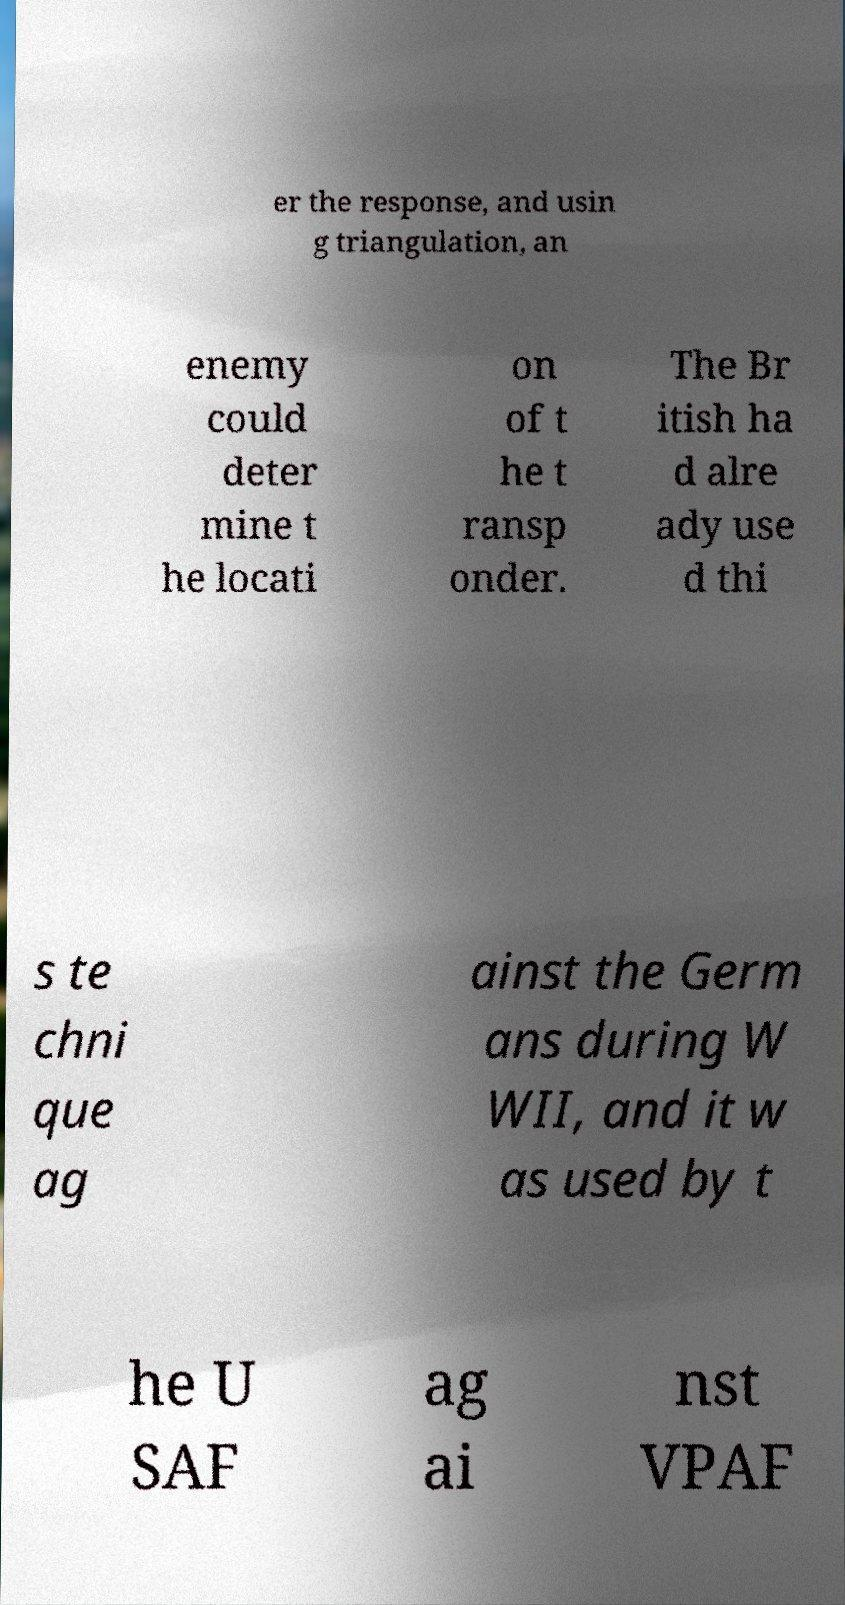Could you extract and type out the text from this image? er the response, and usin g triangulation, an enemy could deter mine t he locati on of t he t ransp onder. The Br itish ha d alre ady use d thi s te chni que ag ainst the Germ ans during W WII, and it w as used by t he U SAF ag ai nst VPAF 